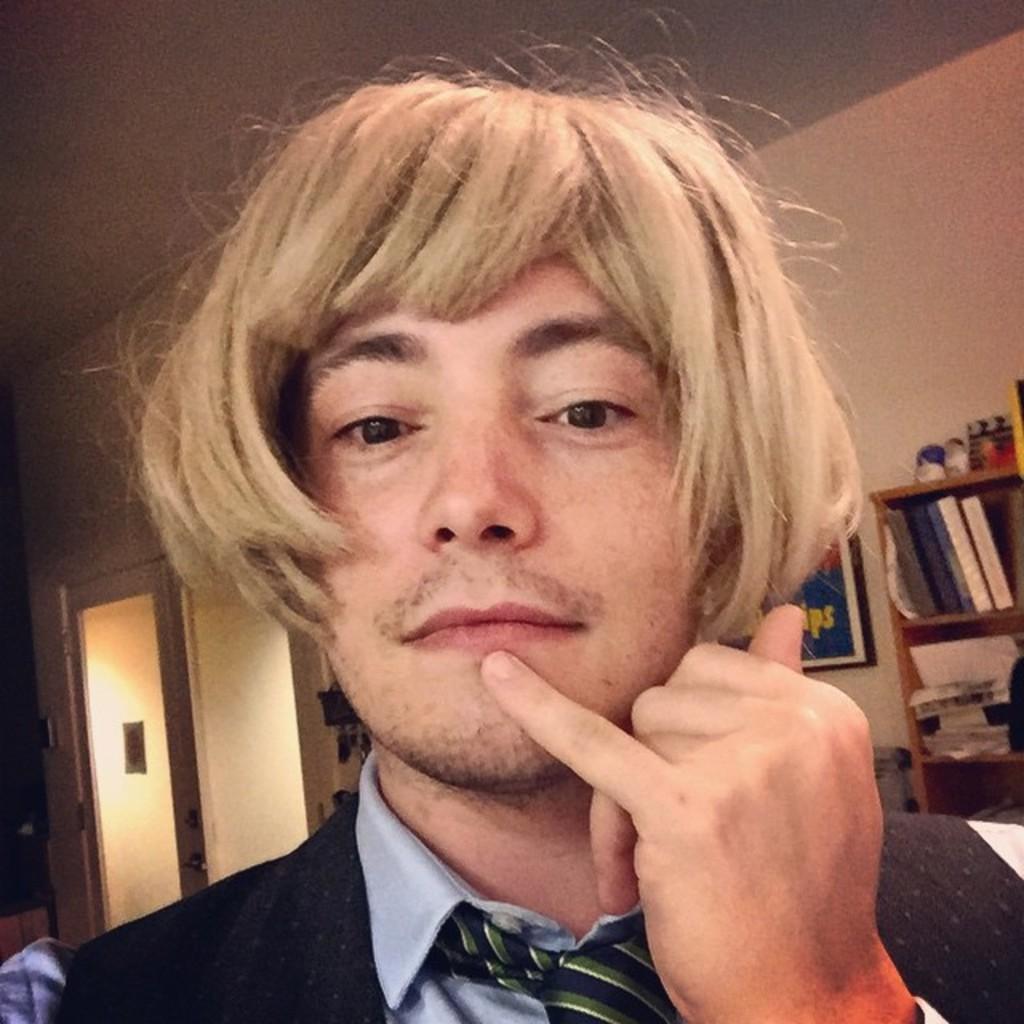Can you describe this image briefly? This picture shows the inner view of a building. There is one poster attached to the glass door, some objects on the cupboard, some objects attached to the wall in the background, some objects near the wall, the background is dark, one man in a suit in the middle of the image, some books and objects in the wooden cupboard on the right side of the image. Two objects on the bottom left and right side corner of the image. 